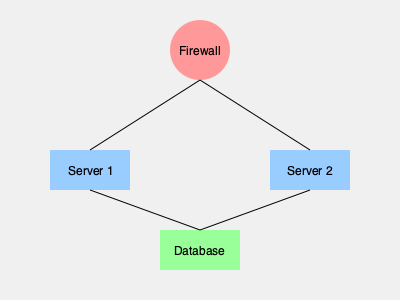Based on the network topology diagram, which component represents the most critical point of vulnerability for the credit union's network security? To analyze the security vulnerabilities of the credit union's network using the provided network topology diagram, we need to consider the following steps:

1. Identify the components:
   - Firewall (at the top)
   - Two servers (Server 1 and Server 2)
   - Database (at the bottom)

2. Analyze the connections:
   - The firewall is connected to both servers
   - Both servers are connected to the database

3. Evaluate the importance of each component:
   - Firewall: Acts as the first line of defense against external threats
   - Servers: Host applications and services for digital banking
   - Database: Stores critical customer and financial data

4. Assess the potential impact of a breach:
   - Firewall breach: Could expose the entire network to external attacks
   - Server breach: May compromise specific applications or services
   - Database breach: Could lead to unauthorized access to sensitive information

5. Consider the single point of failure:
   - The firewall is the only component that controls access to the entire network

6. Evaluate the potential attack surface:
   - The firewall has the largest attack surface as it faces the external network

Based on this analysis, the firewall represents the most critical point of vulnerability. If compromised, it could potentially expose the entire network, including both servers and the database, to external threats. As the single point of entry for external traffic, its security is paramount to protecting the credit union's digital assets and customer information.
Answer: Firewall 